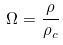<formula> <loc_0><loc_0><loc_500><loc_500>\Omega = \frac { \rho } { \rho _ { c } }</formula> 